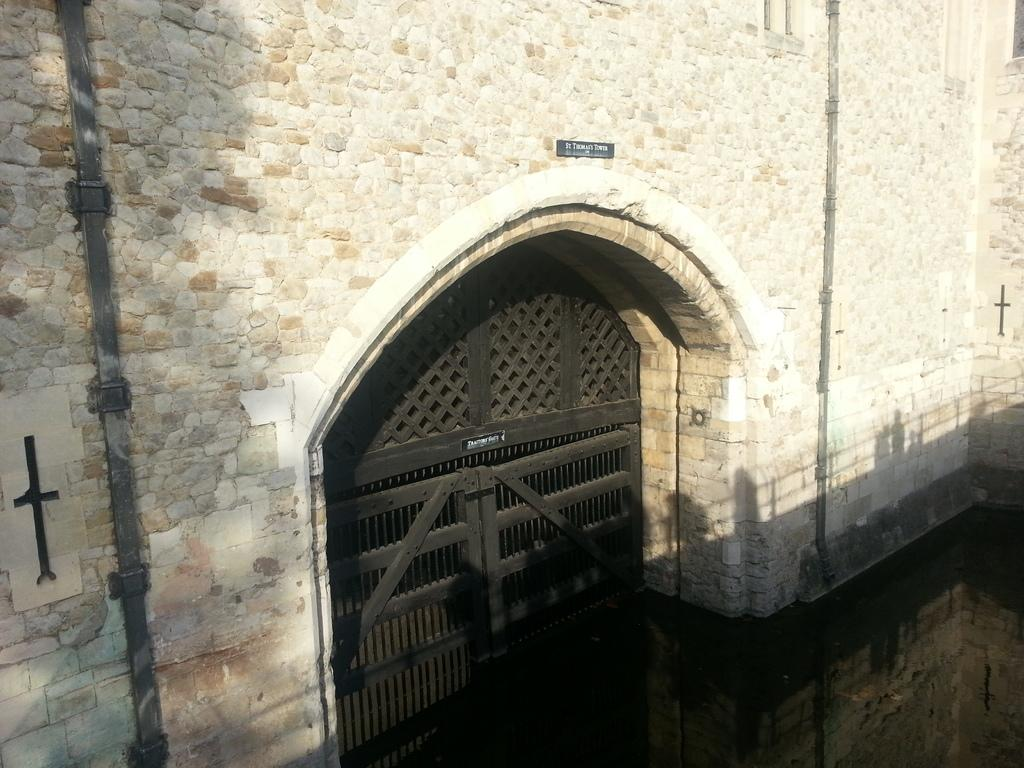What type of structure is present in the image? There is a building in the image. What can be seen on the building? There is a board with text on the building. How can people enter the building? There are doors visible on the building. What is in front of the building? There is water in front of the building. What type of meat is being prepared in the sink in the image? There is no sink or meat present in the image. 